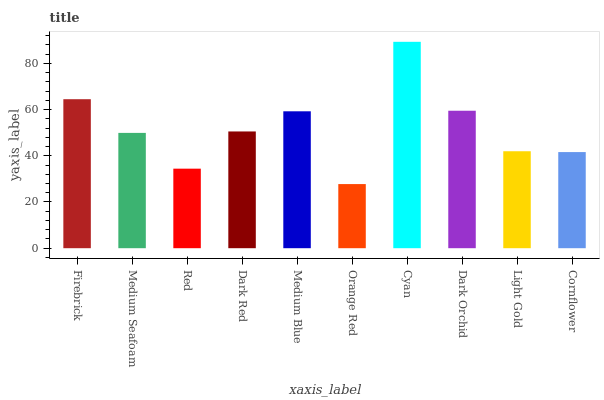Is Medium Seafoam the minimum?
Answer yes or no. No. Is Medium Seafoam the maximum?
Answer yes or no. No. Is Firebrick greater than Medium Seafoam?
Answer yes or no. Yes. Is Medium Seafoam less than Firebrick?
Answer yes or no. Yes. Is Medium Seafoam greater than Firebrick?
Answer yes or no. No. Is Firebrick less than Medium Seafoam?
Answer yes or no. No. Is Dark Red the high median?
Answer yes or no. Yes. Is Medium Seafoam the low median?
Answer yes or no. Yes. Is Cornflower the high median?
Answer yes or no. No. Is Medium Blue the low median?
Answer yes or no. No. 